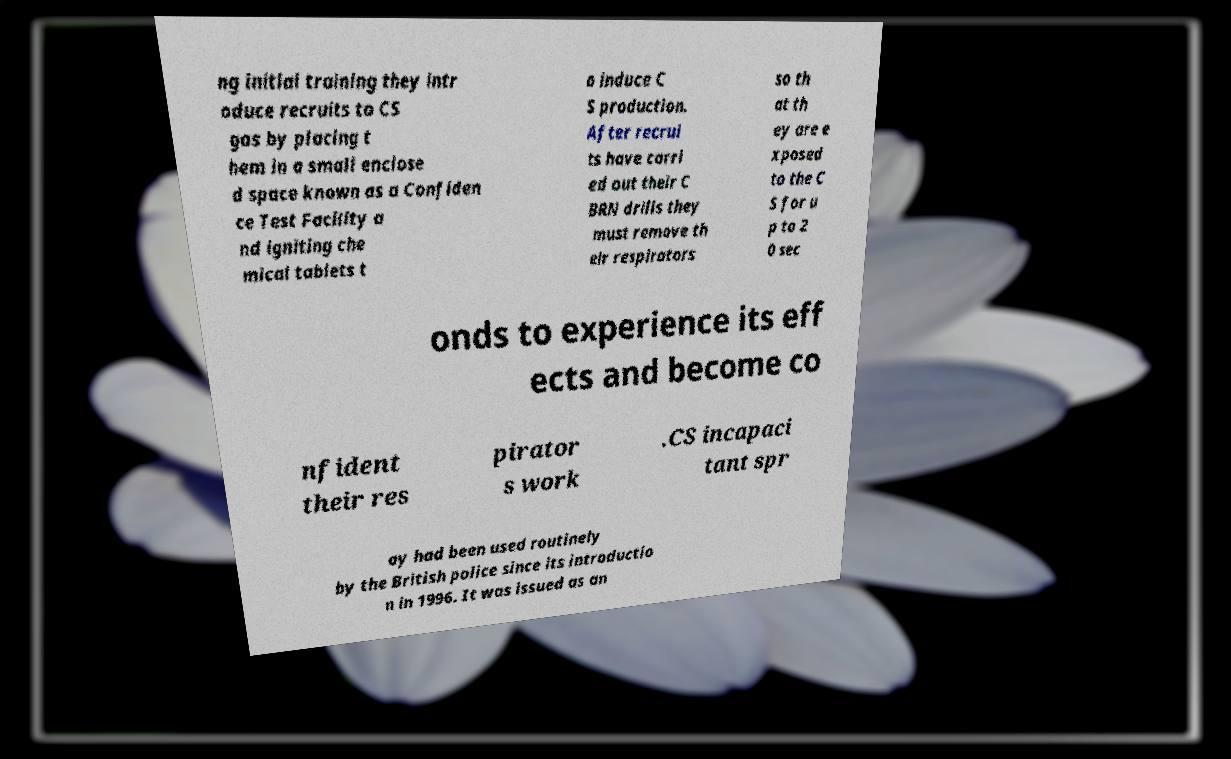What messages or text are displayed in this image? I need them in a readable, typed format. ng initial training they intr oduce recruits to CS gas by placing t hem in a small enclose d space known as a Confiden ce Test Facility a nd igniting che mical tablets t o induce C S production. After recrui ts have carri ed out their C BRN drills they must remove th eir respirators so th at th ey are e xposed to the C S for u p to 2 0 sec onds to experience its eff ects and become co nfident their res pirator s work .CS incapaci tant spr ay had been used routinely by the British police since its introductio n in 1996. It was issued as an 